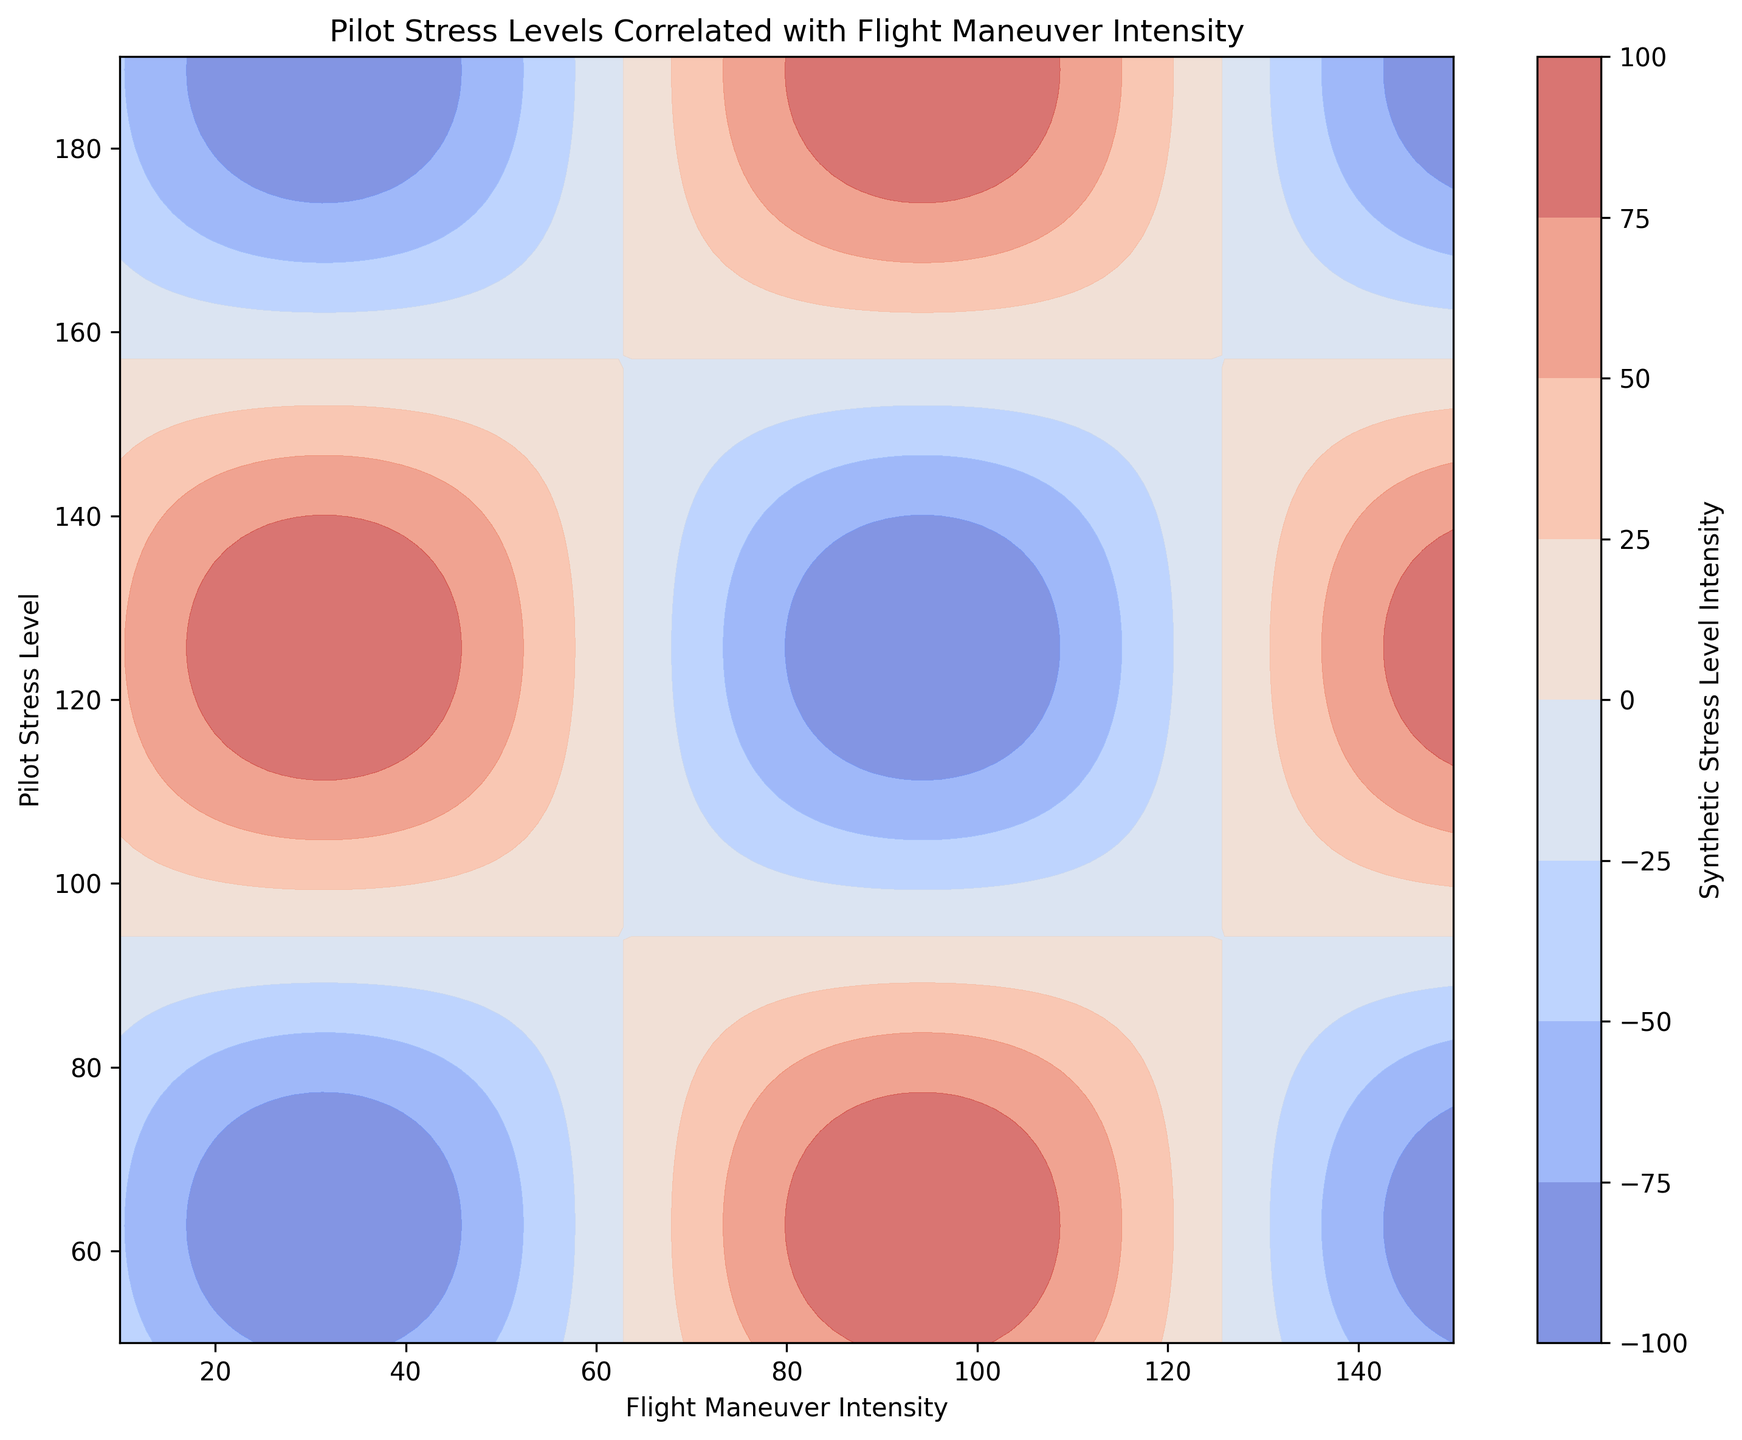What is the range of the Flight Maneuver Intensity in the chart? To find the range of the Flight Maneuver Intensity, identify the minimum and maximum values on the x-axis. The minimum value is 10 and the maximum value is 150. So, the range is 150 - 10.
Answer: 140 In which region does the pilot experience the highest stress levels according to the color scale? Look for the areas on the contour plot that utilize the darkest or most intense color within the color scale, indicating maximum synthetic stress intensity. According to the color scale, the highest stress levels (dark red) occur near the bottom-left, around low maneuver intensities and low to moderate stress levels.
Answer: Bottom-left Compare the stress levels at Flight Maneuver Intensities of 40 and 120. Which one is higher? Observe the contour lines or the color regions at these specific x-axis locations. For an intensity of 40, the color is lighter, whereas for 120, it moves towards a darker shade. According to the color bar, darker shades indicate higher stress levels.
Answer: 120 What happens to the pilot stress levels as Flight Maneuver Intensity increases from 10 to 150, generally? By looking at the contour colors from left to right (as the x-axis increases), the colors generally change from lighter to darker, suggesting an overall increase in stress levels as the Flight Maneuver Intensity increases.
Answer: Increases Estimate the pilot stress level at a Flight Maneuver Intensity of 100 and analyze its correlation on the grid. First, locate 100 on the x-axis. Then follow vertically to where it intersects with significant contour lines or color gradients. This point corresponds with a moderately high color intensity implying a considerable stress level varying between 100 to 140 on a conventional scale.
Answer: Moderate to high What relation can you observe between Flight Maneuver Intensity and Pilot Stress Level overall? Examining the entire contour plot, you will find that higher Flight Maneuver Intensities generally correspond to increased pilot stress levels, illustrated by the progressive darkening of color as you move from bottom-left to upper-right in the diagram.
Answer: Positive correlation Is there any specific Flight Maneuver Intensity where the pilot stress level changes abruptly? Examine the spacing of the contour lines. Lines close together represent a more rapid change in stress level. Around 20 to 40 on the x-axis, we see such spacing indicating stress levels increase more abruptly with increased maneuver intensity between these values.
Answer: Between 20 and 40 Determine the Flight Maneuver Intensity that correlates with a nominal pilot stress level of 90. Identify the corresponding y-axis value of 90 and follow this horizontally until it intersects with prominent color regions or contour lines. At this intersection, note the x-axis Flight Maneuver Intensity value. This correlates to around 70 Flight Maneuver Intensity.
Answer: 70 Compare the widths of regions where the stress levels are significantly lower and higher. Where do you see larger areas? Observe the areas with lighter colors (indicating lower stress levels) and darker colors (indicating higher stress levels). The regions with lower stress levels (generally to the bottom-left) appear more extensive compared to those with highest stress intensity.
Answer: Lower stress areas 